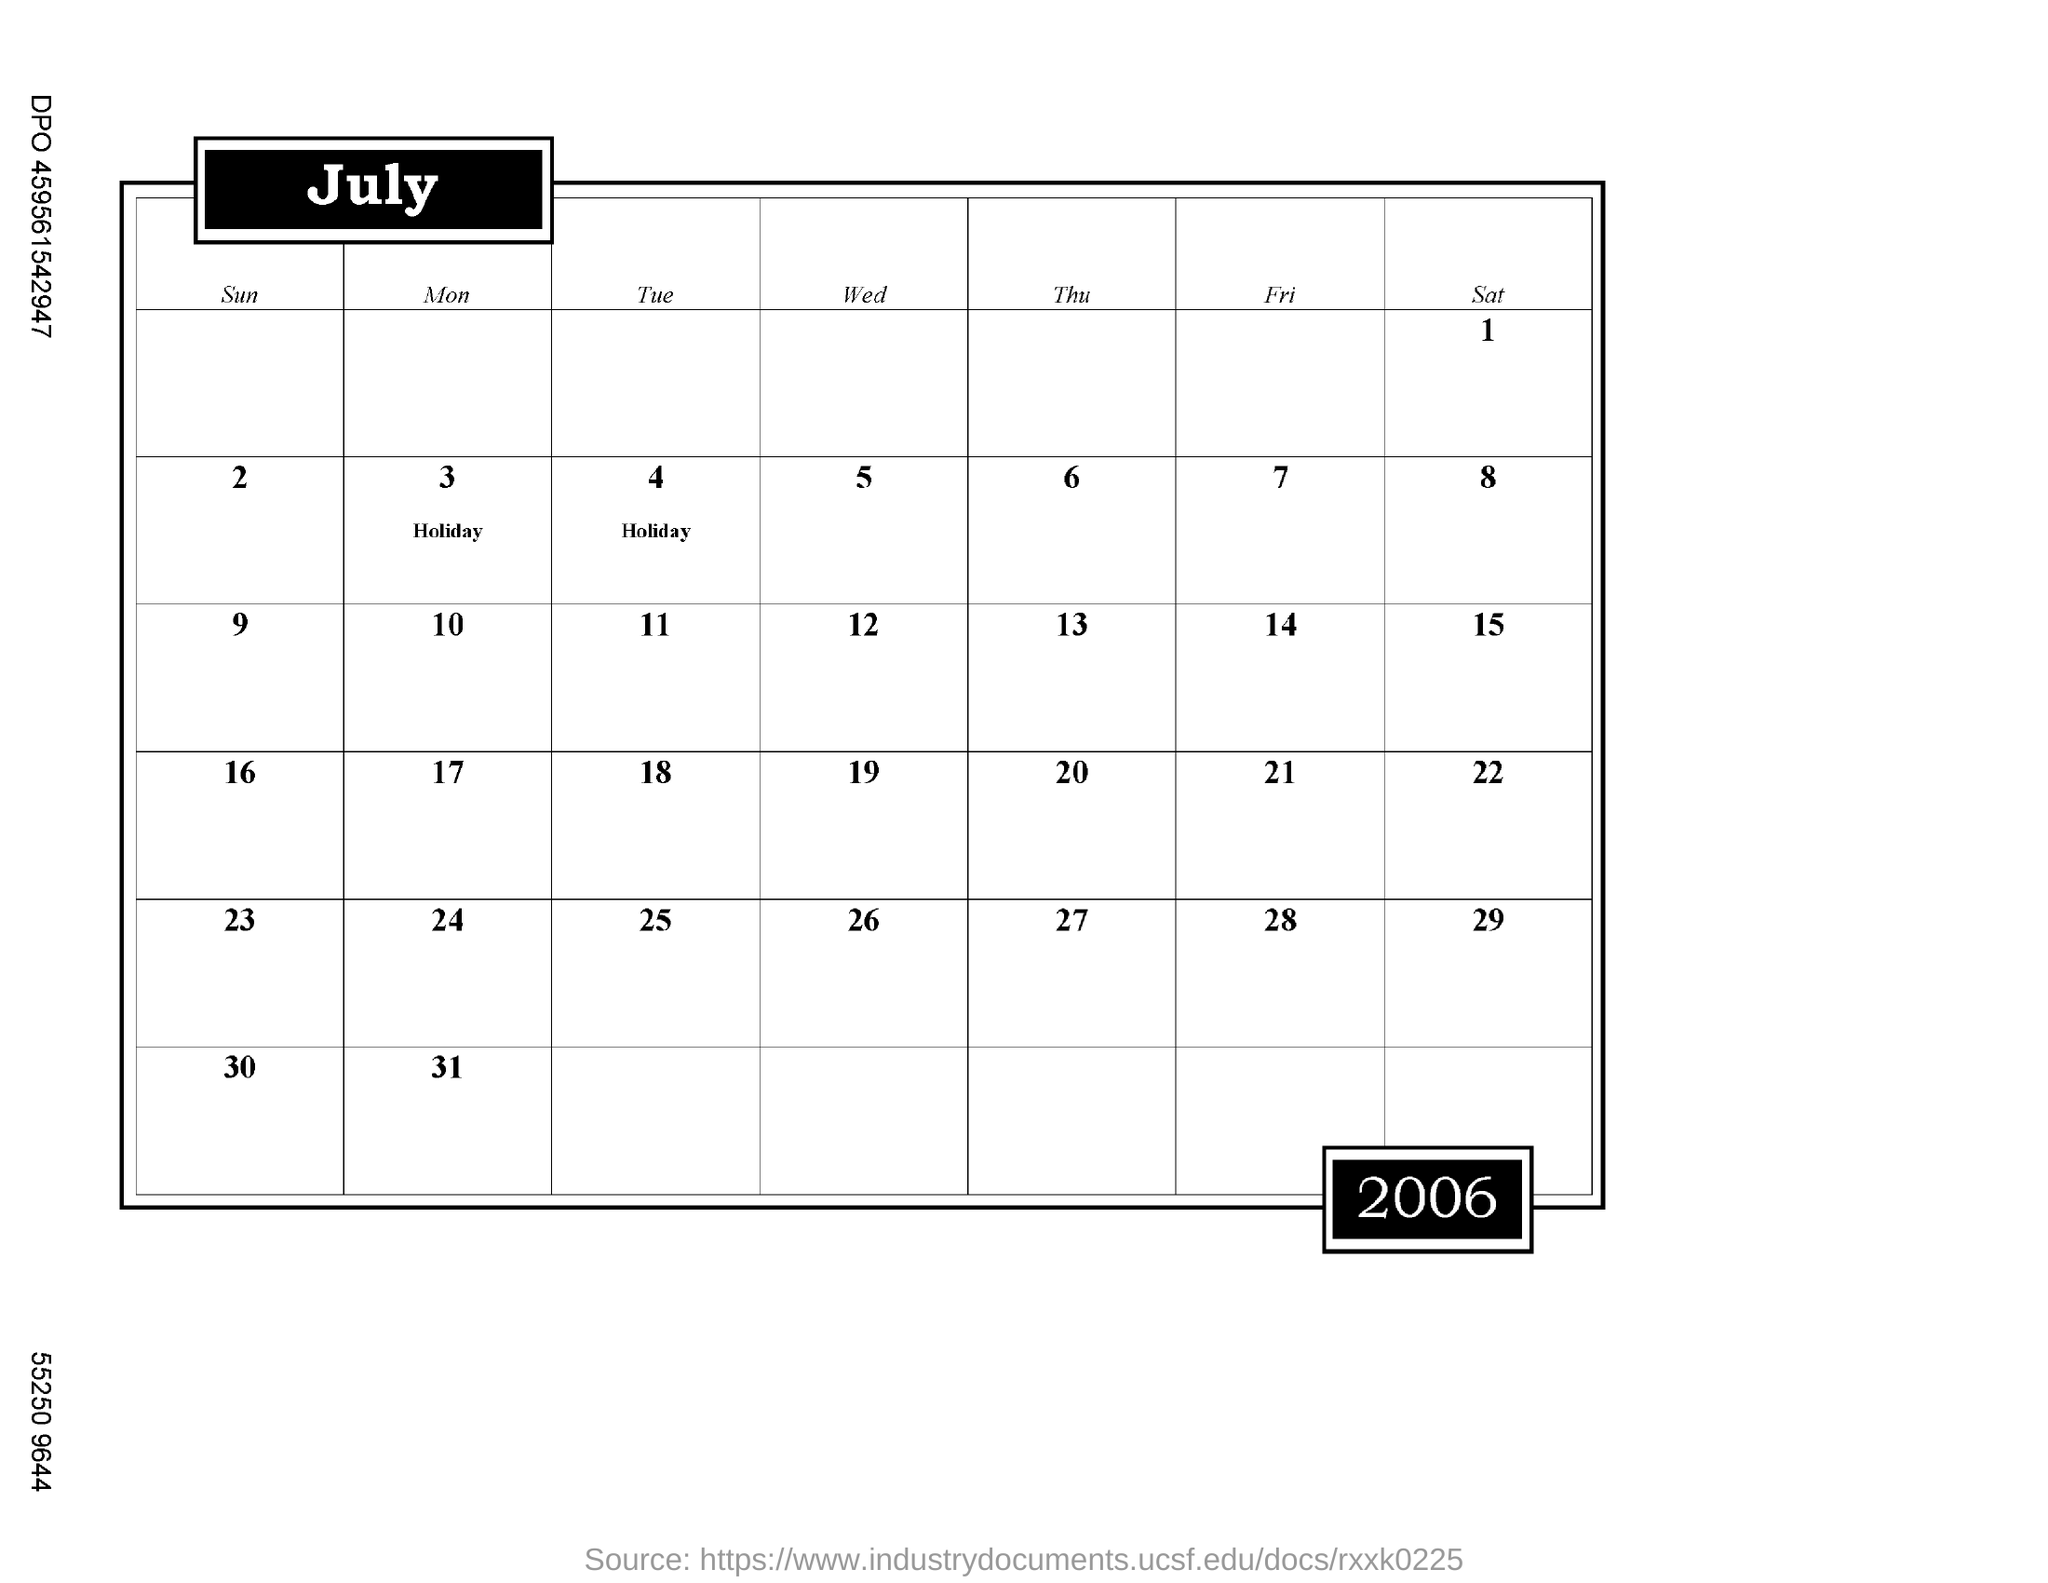Which month's calender is this?
Your answer should be very brief. July. Which year's calender is this?
Give a very brief answer. 2006. When is the first holiday date marked in the calender?
Provide a short and direct response. 3. When is the second holiday date marked in the calender?
Your response must be concise. 4. When is the second saturday of this month?
Keep it short and to the point. 8. How many days are there in July 2006?
Provide a succinct answer. 31. 